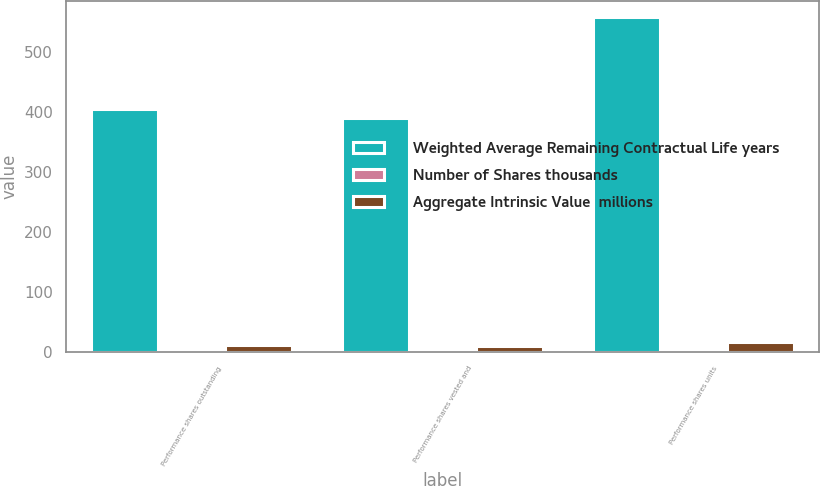Convert chart to OTSL. <chart><loc_0><loc_0><loc_500><loc_500><stacked_bar_chart><ecel><fcel>Performance shares outstanding<fcel>Performance shares vested and<fcel>Performance shares units<nl><fcel>Weighted Average Remaining Contractual Life years<fcel>405<fcel>390<fcel>557<nl><fcel>Number of Shares thousands<fcel>0.41<fcel>0.39<fcel>0.58<nl><fcel>Aggregate Intrinsic Value  millions<fcel>11<fcel>10.4<fcel>16.2<nl></chart> 